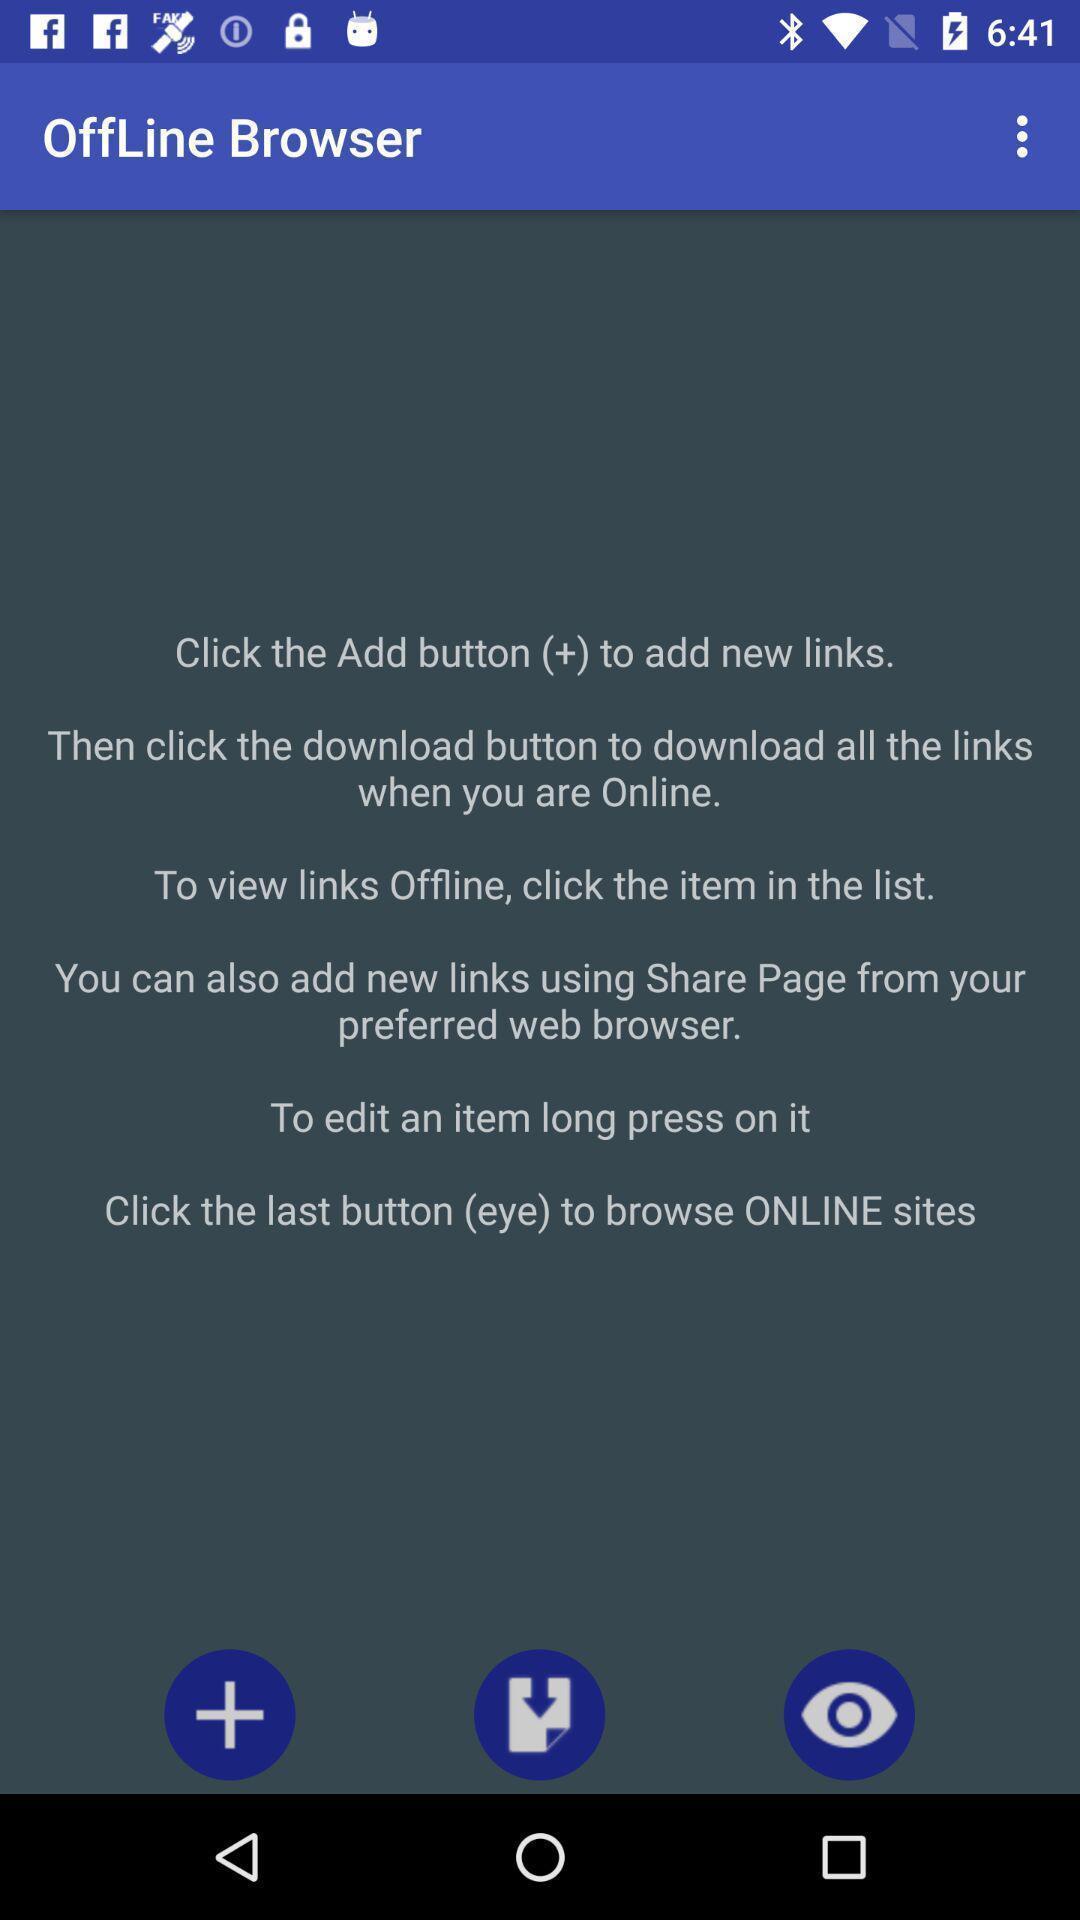What is the overall content of this screenshot? Page showing steps to use the browser on an app. 